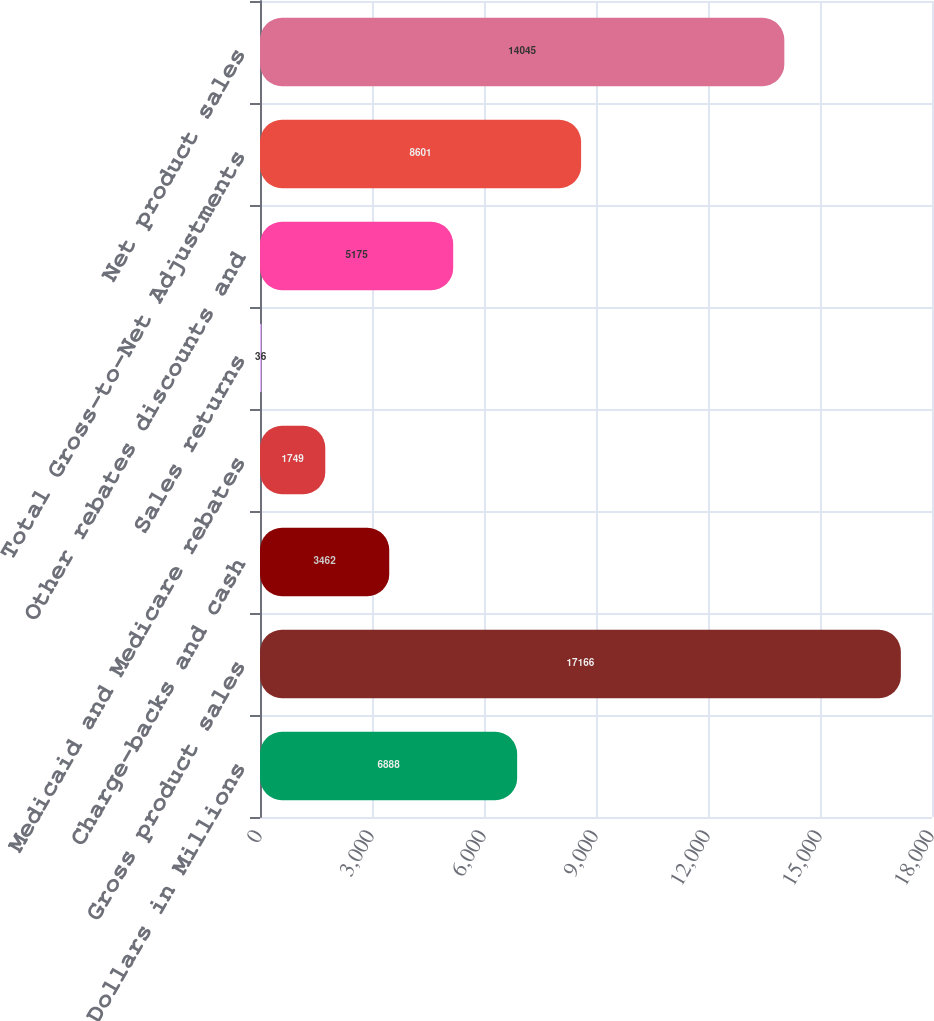Convert chart to OTSL. <chart><loc_0><loc_0><loc_500><loc_500><bar_chart><fcel>Dollars in Millions<fcel>Gross product sales<fcel>Charge-backs and cash<fcel>Medicaid and Medicare rebates<fcel>Sales returns<fcel>Other rebates discounts and<fcel>Total Gross-to-Net Adjustments<fcel>Net product sales<nl><fcel>6888<fcel>17166<fcel>3462<fcel>1749<fcel>36<fcel>5175<fcel>8601<fcel>14045<nl></chart> 